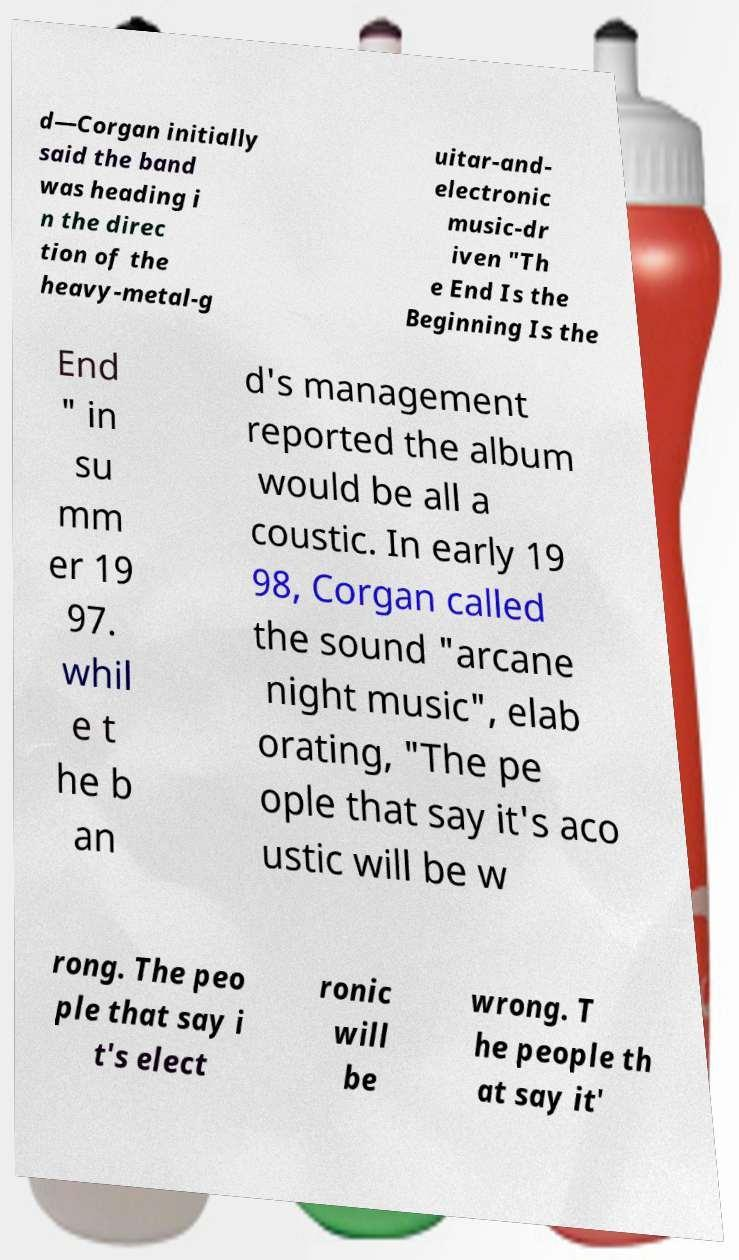Could you assist in decoding the text presented in this image and type it out clearly? d—Corgan initially said the band was heading i n the direc tion of the heavy-metal-g uitar-and- electronic music-dr iven "Th e End Is the Beginning Is the End " in su mm er 19 97. whil e t he b an d's management reported the album would be all a coustic. In early 19 98, Corgan called the sound "arcane night music", elab orating, "The pe ople that say it's aco ustic will be w rong. The peo ple that say i t's elect ronic will be wrong. T he people th at say it' 